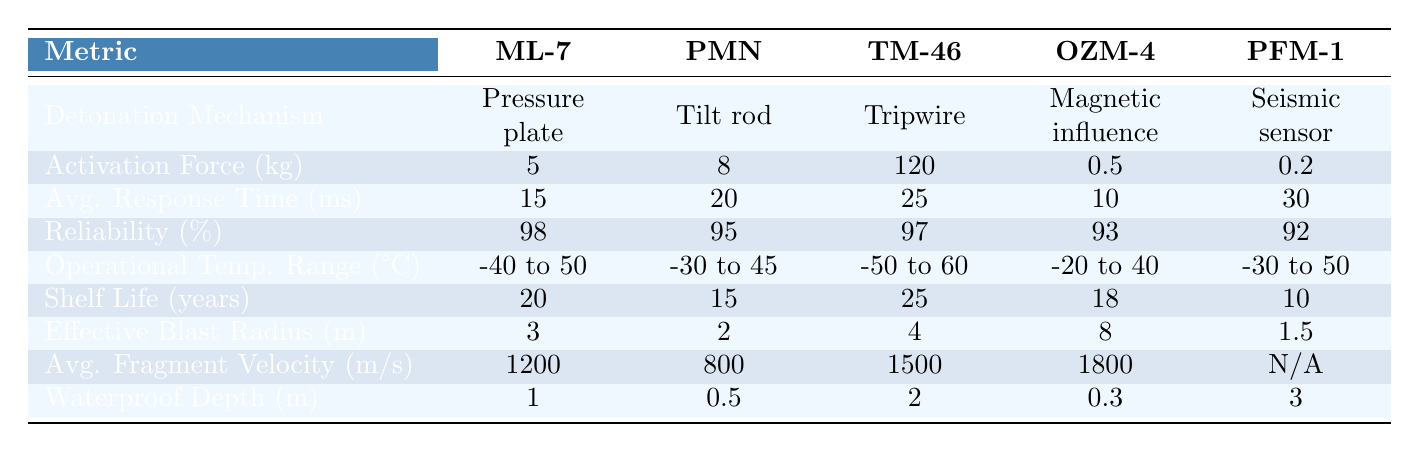What are the activation forces of the ML-7 and PFM-1 mines? The activation force for the ML-7 is 5 kg and for the PFM-1 is 0.2 kg, as listed in the table under "Activation Force (kg)."
Answer: 5 kg and 0.2 kg Which mine has the highest average response time? By comparing the "Avg. Response Time (ms)" values, TM-46 has the highest value at 25 ms.
Answer: TM-46 What is the reliability percentage of the OZM-4 mine? The reliability percentage for OZM-4 is 93%, which can be found in the "Reliability (%)" row under the corresponding mine's column.
Answer: 93% Is the average fragment velocity for the PFM-1 mine available? In the table, the average fragment velocity for PFM-1 is listed as N/A, indicating that there is no data available for this mine's fragment velocity.
Answer: No What is the difference in effective blast radius between the OZM-4 and ML-7 mines? The effective blast radius for OZM-4 is 8 meters and for ML-7 is 3 meters. The difference is 8 - 3 = 5 meters.
Answer: 5 meters Which mine type has the longest shelf life, and what is that duration? By examining the "Shelf Life (years)" data, TM-46 has the longest shelf life of 25 years.
Answer: TM-46, 25 years What is the average activation force of all the mines listed? To find the average activation force, sum the activation forces: 5 + 8 + 120 + 0.5 + 0.2 = 133.7 kg and divide by the number of mines (5), resulting in an average of 26.74 kg.
Answer: 26.74 kg How many mine types have a waterproof depth greater than 1 meter? By reviewing the "Waterproof Depth (m)," only the PFM-1 (3 m) and TM-46 (2 m) exceed 1 meter, totaling 2 mine types.
Answer: 2 What is the operational temperature range for the TM-46 mine? The operational temperature range for the TM-46 is -50 to 60 °C, as stated in the "Operational Temp. Range (°C)" row for that mine.
Answer: -50 to 60 °C Which mine has the shortest average response time and what is it? The OZM-4 mine has the shortest average response time of 10 ms, which is noted in the "Avg. Response Time (ms)" row for that mine.
Answer: 10 ms 